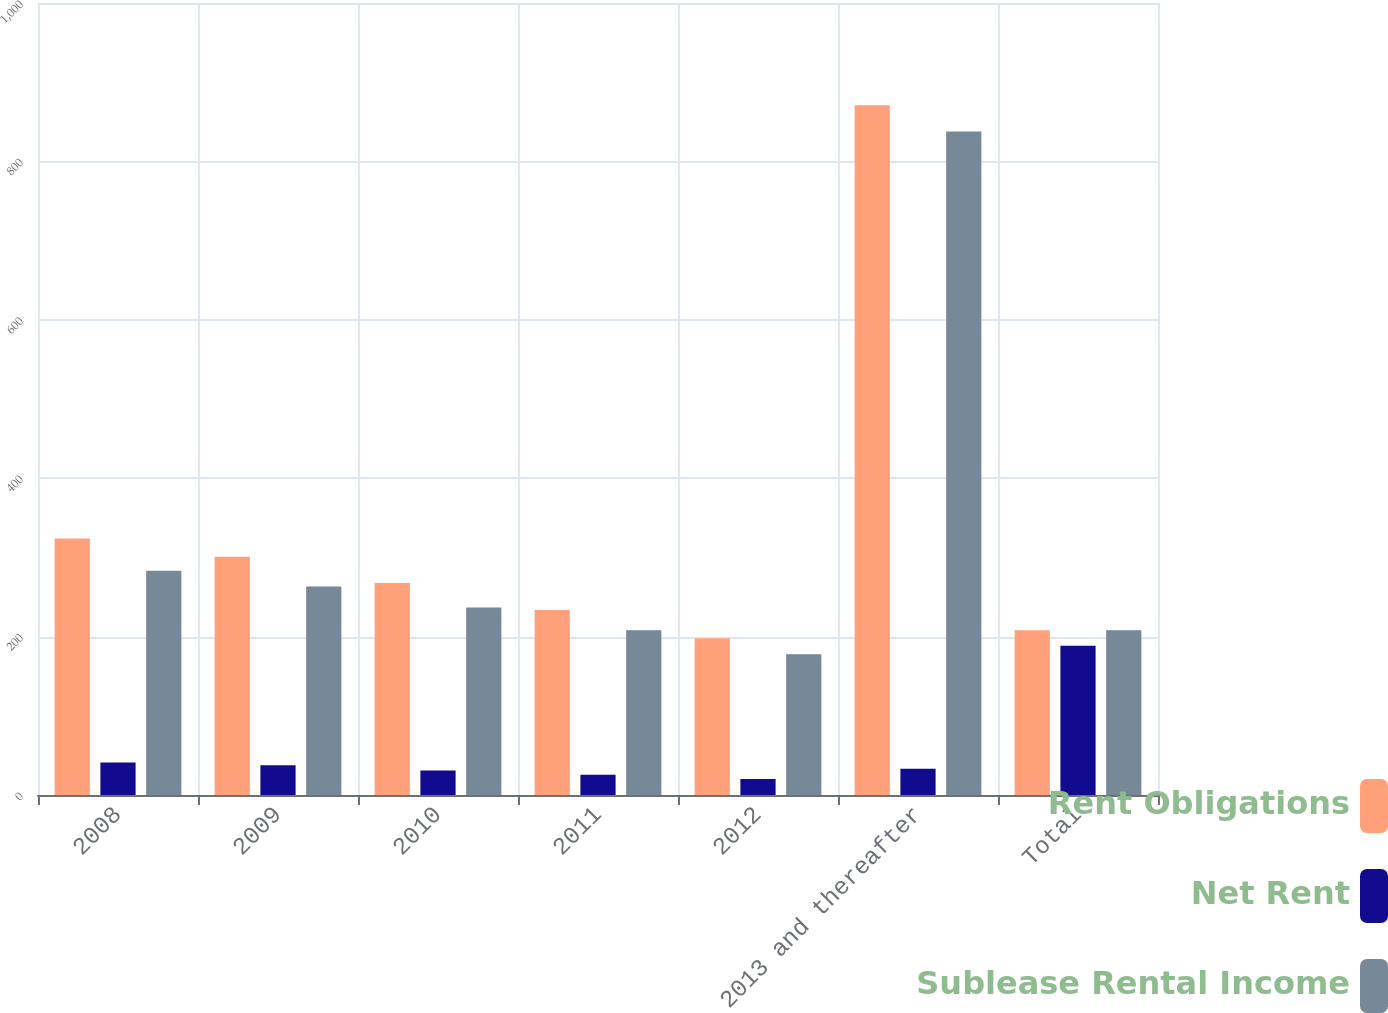Convert chart. <chart><loc_0><loc_0><loc_500><loc_500><stacked_bar_chart><ecel><fcel>2008<fcel>2009<fcel>2010<fcel>2011<fcel>2012<fcel>2013 and thereafter<fcel>Total<nl><fcel>Rent Obligations<fcel>323.9<fcel>300.9<fcel>267.7<fcel>233.7<fcel>197.9<fcel>871<fcel>208<nl><fcel>Net Rent<fcel>40.9<fcel>37.5<fcel>31<fcel>25.7<fcel>20.2<fcel>33.1<fcel>188.4<nl><fcel>Sublease Rental Income<fcel>283<fcel>263.4<fcel>236.7<fcel>208<fcel>177.7<fcel>837.9<fcel>208<nl></chart> 